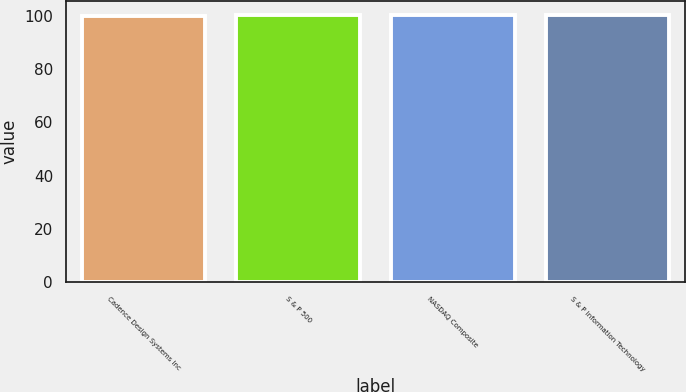Convert chart. <chart><loc_0><loc_0><loc_500><loc_500><bar_chart><fcel>Cadence Design Systems Inc<fcel>S & P 500<fcel>NASDAQ Composite<fcel>S & P Information Technology<nl><fcel>100<fcel>100.1<fcel>100.2<fcel>100.3<nl></chart> 